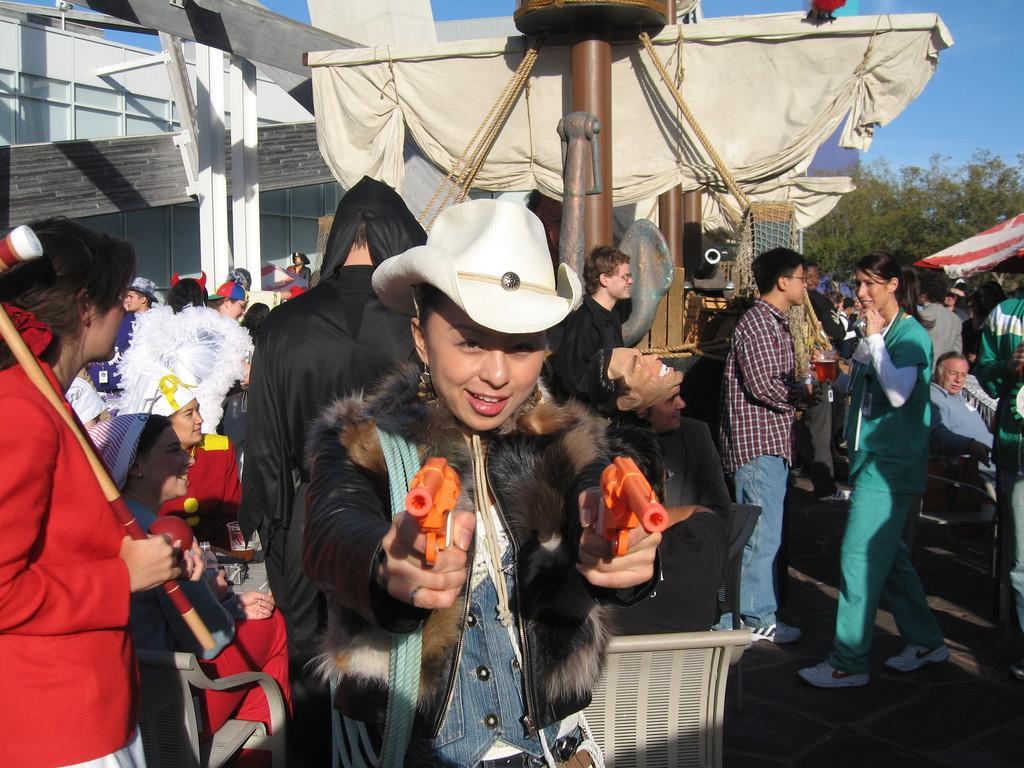Please provide a concise description of this image. In this picture we can see a woman and she is holding guns and in the background we can see a group of people, building, clothes, trees and the sky. 